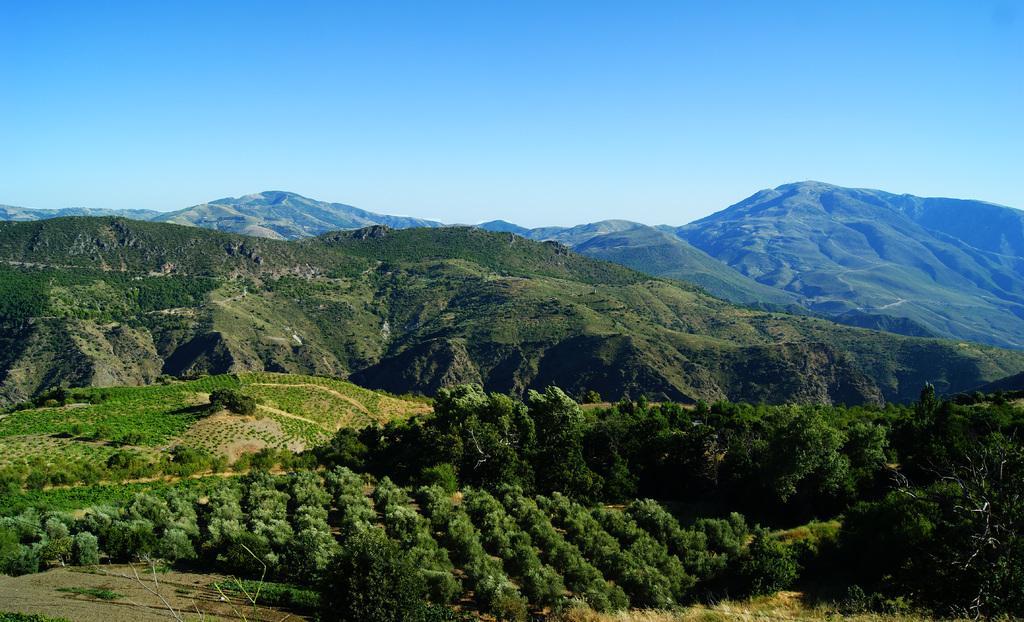In one or two sentences, can you explain what this image depicts? In this image we can see a group of plants, trees, the hills and the sky which looks cloudy. 